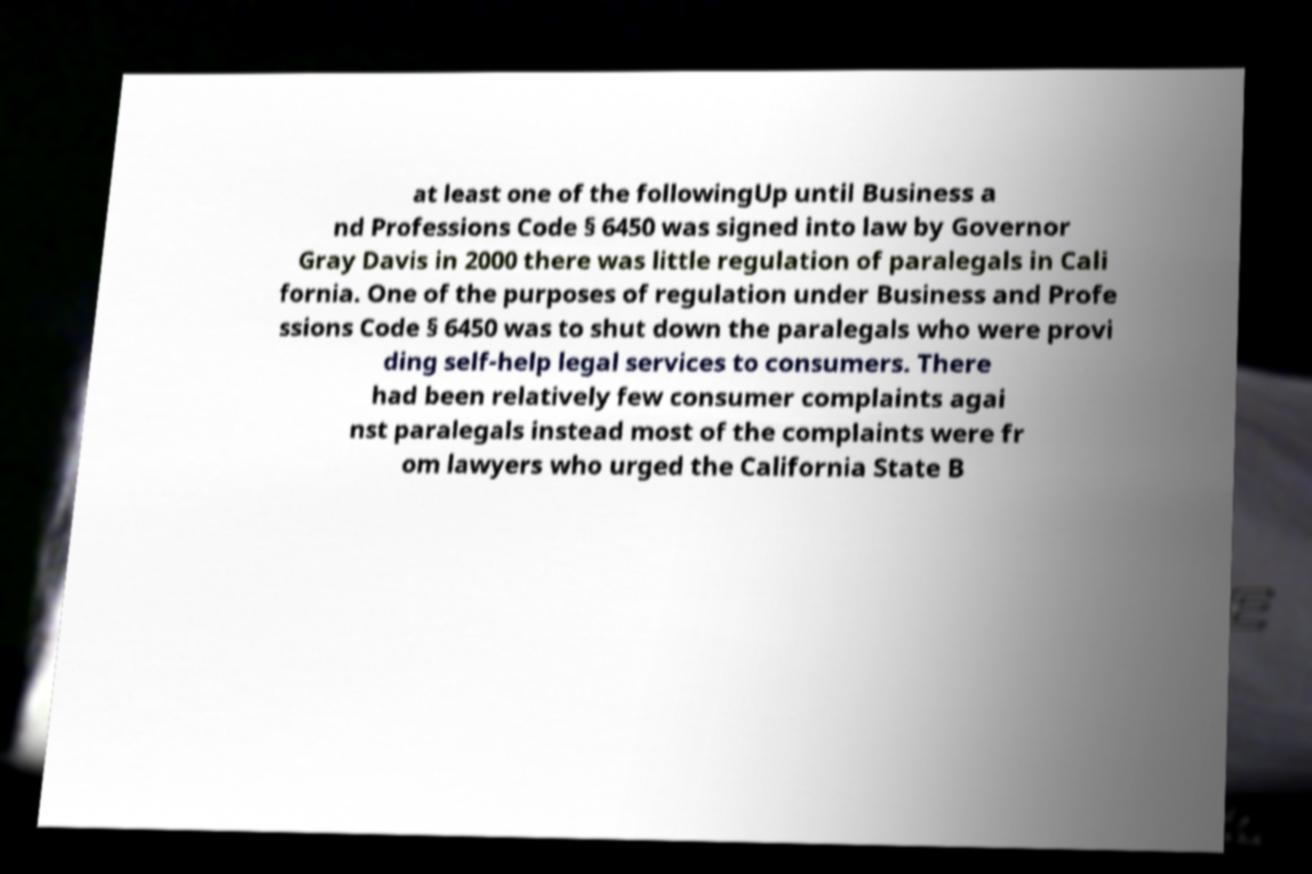What messages or text are displayed in this image? I need them in a readable, typed format. at least one of the followingUp until Business a nd Professions Code § 6450 was signed into law by Governor Gray Davis in 2000 there was little regulation of paralegals in Cali fornia. One of the purposes of regulation under Business and Profe ssions Code § 6450 was to shut down the paralegals who were provi ding self-help legal services to consumers. There had been relatively few consumer complaints agai nst paralegals instead most of the complaints were fr om lawyers who urged the California State B 